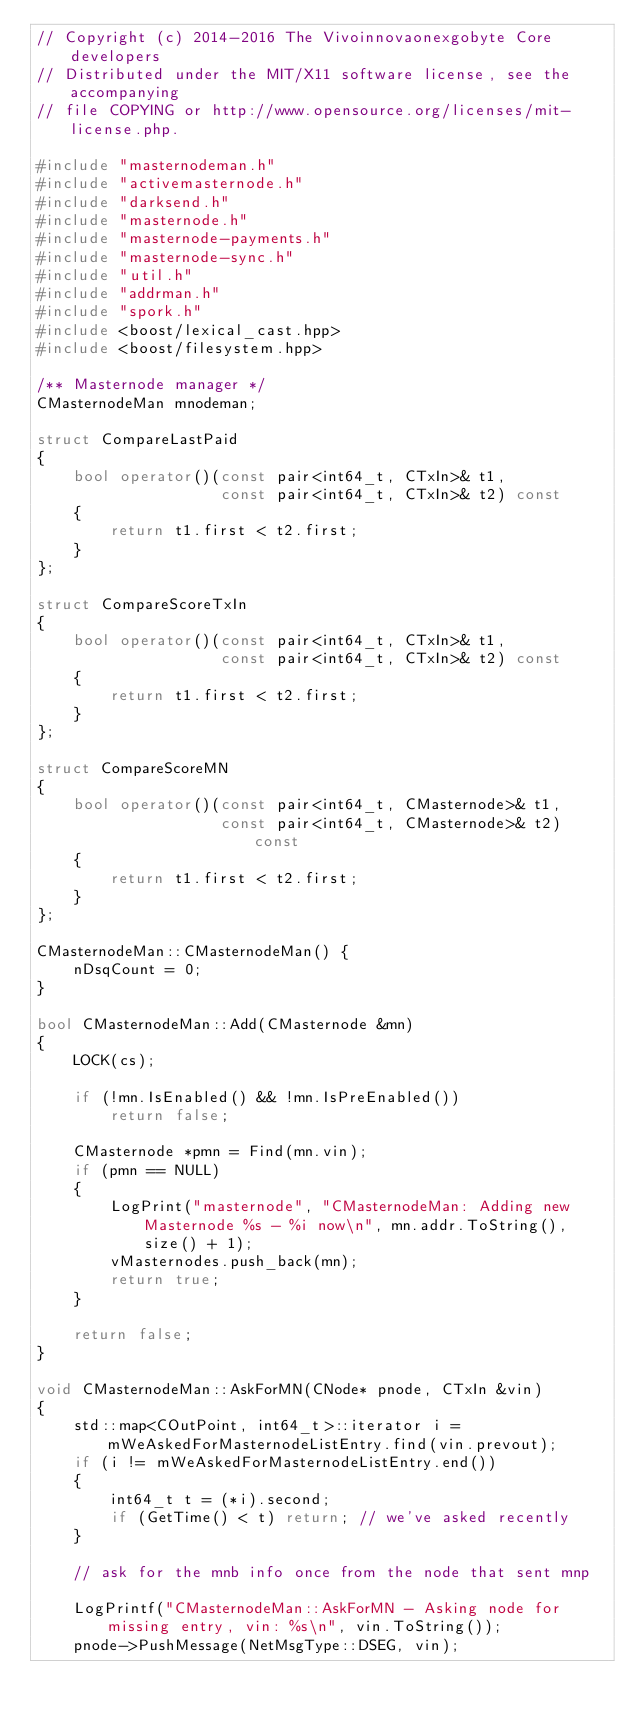<code> <loc_0><loc_0><loc_500><loc_500><_C++_>// Copyright (c) 2014-2016 The Vivoinnovaonexgobyte Core developers
// Distributed under the MIT/X11 software license, see the accompanying
// file COPYING or http://www.opensource.org/licenses/mit-license.php.

#include "masternodeman.h"
#include "activemasternode.h"
#include "darksend.h"
#include "masternode.h"
#include "masternode-payments.h"
#include "masternode-sync.h"
#include "util.h"
#include "addrman.h"
#include "spork.h"
#include <boost/lexical_cast.hpp>
#include <boost/filesystem.hpp>

/** Masternode manager */
CMasternodeMan mnodeman;

struct CompareLastPaid
{
    bool operator()(const pair<int64_t, CTxIn>& t1,
                    const pair<int64_t, CTxIn>& t2) const
    {
        return t1.first < t2.first;
    }
};

struct CompareScoreTxIn
{
    bool operator()(const pair<int64_t, CTxIn>& t1,
                    const pair<int64_t, CTxIn>& t2) const
    {
        return t1.first < t2.first;
    }
};

struct CompareScoreMN
{
    bool operator()(const pair<int64_t, CMasternode>& t1,
                    const pair<int64_t, CMasternode>& t2) const
    {
        return t1.first < t2.first;
    }
};

CMasternodeMan::CMasternodeMan() {
    nDsqCount = 0;
}

bool CMasternodeMan::Add(CMasternode &mn)
{
    LOCK(cs);

    if (!mn.IsEnabled() && !mn.IsPreEnabled())
        return false;

    CMasternode *pmn = Find(mn.vin);
    if (pmn == NULL)
    {
        LogPrint("masternode", "CMasternodeMan: Adding new Masternode %s - %i now\n", mn.addr.ToString(), size() + 1);
        vMasternodes.push_back(mn);
        return true;
    }

    return false;
}

void CMasternodeMan::AskForMN(CNode* pnode, CTxIn &vin)
{
    std::map<COutPoint, int64_t>::iterator i = mWeAskedForMasternodeListEntry.find(vin.prevout);
    if (i != mWeAskedForMasternodeListEntry.end())
    {
        int64_t t = (*i).second;
        if (GetTime() < t) return; // we've asked recently
    }

    // ask for the mnb info once from the node that sent mnp

    LogPrintf("CMasternodeMan::AskForMN - Asking node for missing entry, vin: %s\n", vin.ToString());
    pnode->PushMessage(NetMsgType::DSEG, vin);</code> 